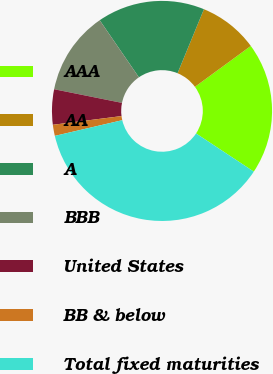<chart> <loc_0><loc_0><loc_500><loc_500><pie_chart><fcel>AAA<fcel>AA<fcel>A<fcel>BBB<fcel>United States<fcel>BB & below<fcel>Total fixed maturities<nl><fcel>19.35%<fcel>8.72%<fcel>15.8%<fcel>12.26%<fcel>5.17%<fcel>1.63%<fcel>37.06%<nl></chart> 